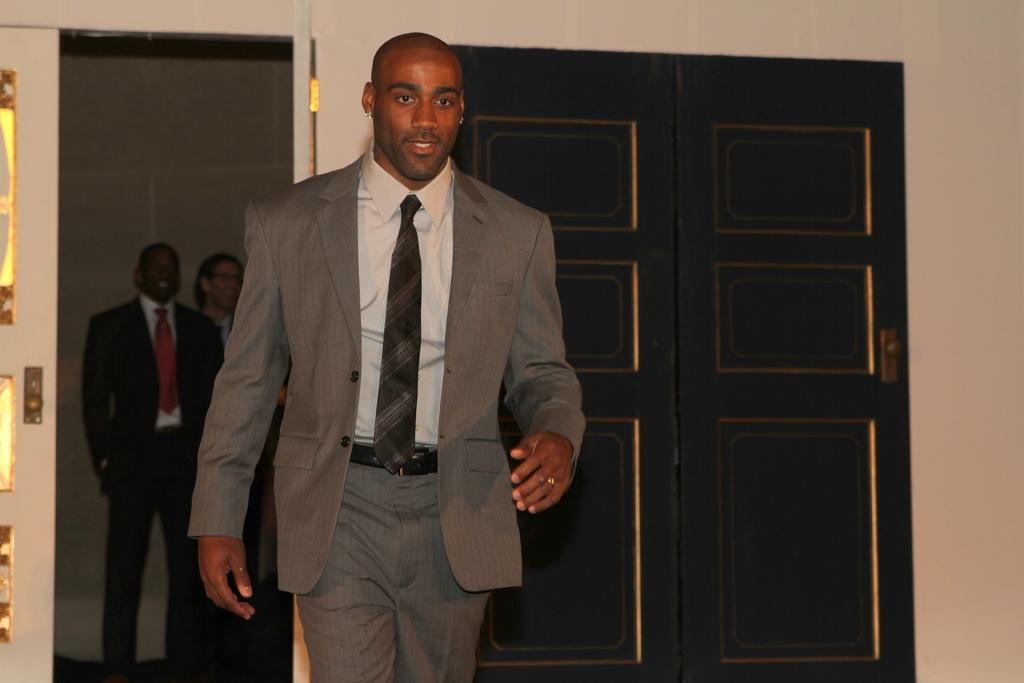What is the person in the image doing? There is a person walking in the image. What type of clothing is the person wearing? The person is wearing a blazer and a tie. What can be seen in the background of the image? There are people standing in the background of the image, and there is a wall with doors. What type of muscle is visible on the person's arm in the image? There is no muscle visible on the person's arm in the image, as the focus is on their clothing and not their physique. 